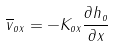Convert formula to latex. <formula><loc_0><loc_0><loc_500><loc_500>\overline { v } _ { o x } = - K _ { o x } \frac { \partial h _ { o } } { \partial x }</formula> 